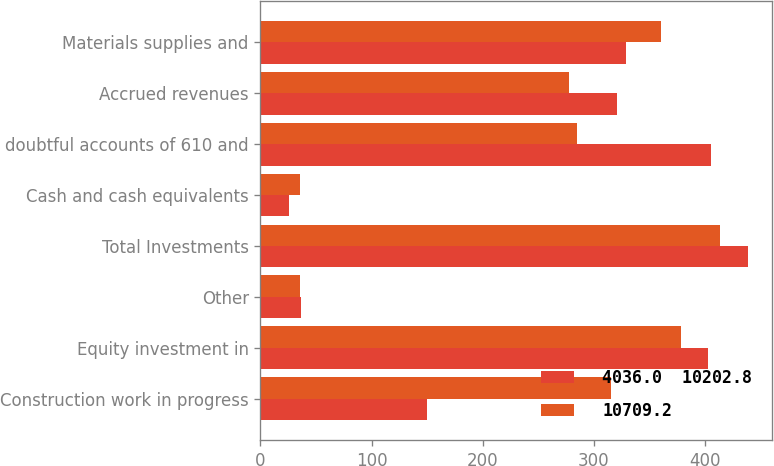<chart> <loc_0><loc_0><loc_500><loc_500><stacked_bar_chart><ecel><fcel>Construction work in progress<fcel>Equity investment in<fcel>Other<fcel>Total Investments<fcel>Cash and cash equivalents<fcel>doubtful accounts of 610 and<fcel>Accrued revenues<fcel>Materials supplies and<nl><fcel>4036.0  10202.8<fcel>149.6<fcel>402.7<fcel>36.1<fcel>438.8<fcel>26<fcel>406<fcel>321.1<fcel>329.4<nl><fcel>10709.2<fcel>315.9<fcel>378.3<fcel>35.5<fcel>413.8<fcel>35.6<fcel>285.3<fcel>278.1<fcel>360.7<nl></chart> 